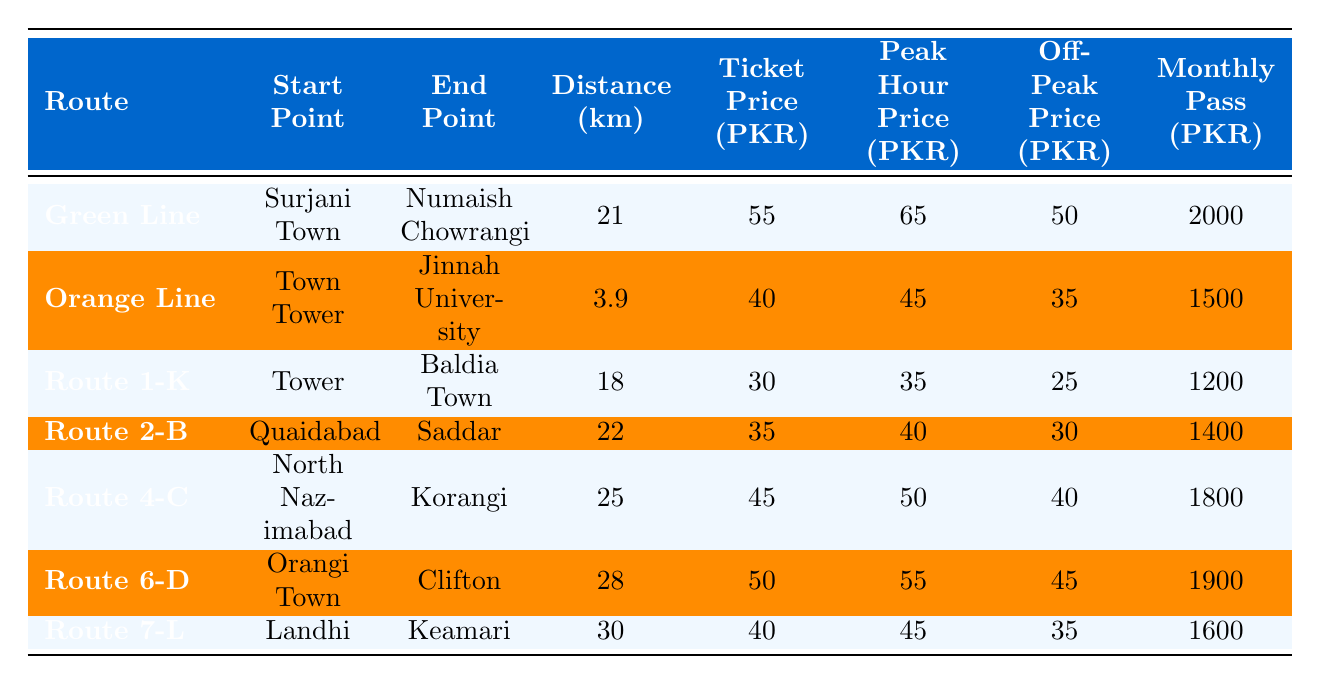What is the ticket price for the Orange Line route? The ticket price for the Orange Line, which runs from Town Tower to Jinnah University, is listed directly in the table. It shows a ticket price of 40 PKR.
Answer: 40 PKR Which route has the highest monthly pass price? By examining the monthly pass prices for each route in the table, we find that the Green Line has the highest monthly pass price at 2000 PKR compared to other routes.
Answer: Green Line How much is the peak hour price for Route 4-C? The peak hour price for Route 4-C, which goes from North Nazimabad to Korangi, is directly stated in the table as 50 PKR.
Answer: 50 PKR Which route has the longest distance, and what is that distance? Looking through the distance data in the table, the Route 7-L from Landhi to Keamari is noted to have the longest distance of 30 km among all routes.
Answer: Route 7-L, 30 km What is the difference between the peak hour price and the off-peak price for Route 1-K? To find the difference, subtract the off-peak price of Route 1-K (25 PKR) from its peak hour price (35 PKR). This calculation shows a difference of 10 PKR.
Answer: 10 PKR If a commuter travels the Orange Line during off-peak hours five times a week, how much will they spend on tickets in a month? The off-peak price for the Orange Line is 35 PKR. Assuming there are 4 weeks in a month, the total cost is calculated as follows: 35 PKR * 5 trips/week * 4 weeks = 700 PKR.
Answer: 700 PKR Is the ticket price for Route 6-D more expensive than the ticket price for Route 2-B? Comparing the ticket prices in the table, Route 6-D has a ticket price of 50 PKR while Route 2-B has a ticket price of 35 PKR, confirming that Route 6-D is indeed more expensive.
Answer: Yes What is the monthly pass price for routes with a distance greater than 25 km? The routes greater than 25 km are Route 6-D (28 km) and Route 7-L (30 km). Their respective monthly pass prices are 1900 PKR and 1600 PKR. Therefore, the cost for both is summed to give 1900 + 1600 = 3500 PKR.
Answer: 3500 PKR Which route has the least ticket price, and what is its distance? By reviewing the ticket prices in the table, the route with the least ticket price is Route 1-K at 30 PKR, and it covers a distance of 18 km.
Answer: Route 1-K, 18 km What is the average ticket price across all routes? First, we need to add all ticket prices: 55 + 40 + 30 + 35 + 45 + 50 + 40 = 295 PKR. Since there are 7 routes, we divide by 7: 295 / 7 ≈ 42.14 PKR. Thus, the average ticket price is approximately 42 PKR.
Answer: 42 PKR 